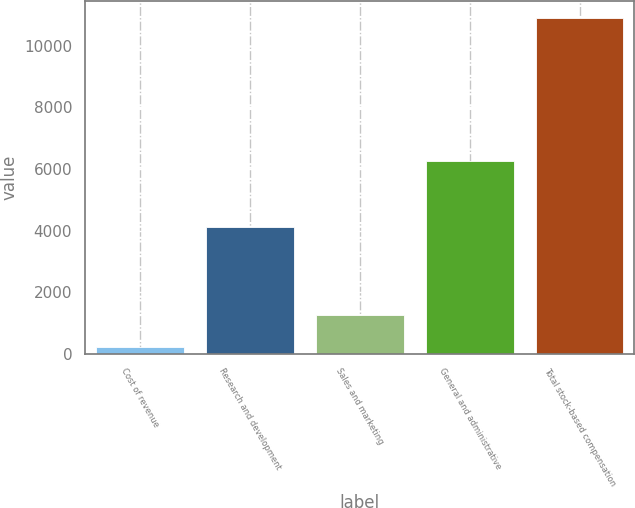Convert chart to OTSL. <chart><loc_0><loc_0><loc_500><loc_500><bar_chart><fcel>Cost of revenue<fcel>Research and development<fcel>Sales and marketing<fcel>General and administrative<fcel>Total stock-based compensation<nl><fcel>200<fcel>4126<fcel>1270<fcel>6261<fcel>10900<nl></chart> 